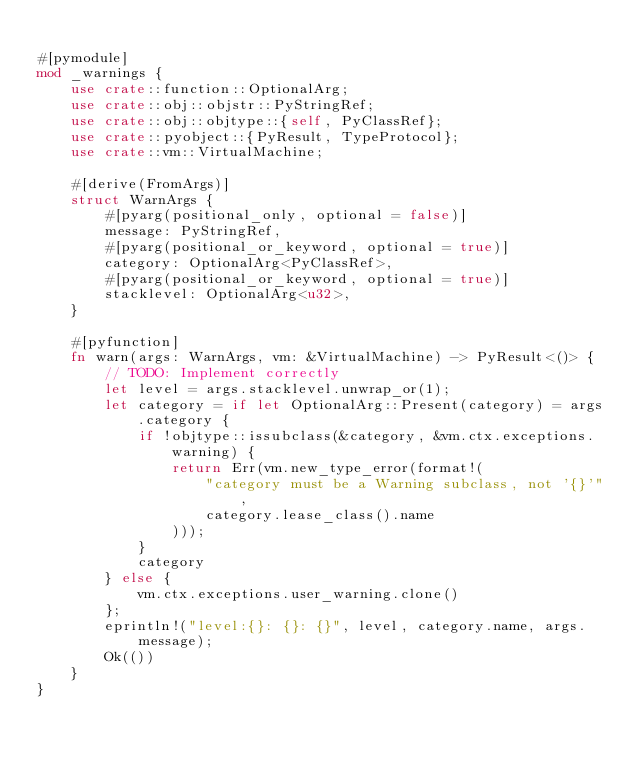<code> <loc_0><loc_0><loc_500><loc_500><_Rust_>
#[pymodule]
mod _warnings {
    use crate::function::OptionalArg;
    use crate::obj::objstr::PyStringRef;
    use crate::obj::objtype::{self, PyClassRef};
    use crate::pyobject::{PyResult, TypeProtocol};
    use crate::vm::VirtualMachine;

    #[derive(FromArgs)]
    struct WarnArgs {
        #[pyarg(positional_only, optional = false)]
        message: PyStringRef,
        #[pyarg(positional_or_keyword, optional = true)]
        category: OptionalArg<PyClassRef>,
        #[pyarg(positional_or_keyword, optional = true)]
        stacklevel: OptionalArg<u32>,
    }

    #[pyfunction]
    fn warn(args: WarnArgs, vm: &VirtualMachine) -> PyResult<()> {
        // TODO: Implement correctly
        let level = args.stacklevel.unwrap_or(1);
        let category = if let OptionalArg::Present(category) = args.category {
            if !objtype::issubclass(&category, &vm.ctx.exceptions.warning) {
                return Err(vm.new_type_error(format!(
                    "category must be a Warning subclass, not '{}'",
                    category.lease_class().name
                )));
            }
            category
        } else {
            vm.ctx.exceptions.user_warning.clone()
        };
        eprintln!("level:{}: {}: {}", level, category.name, args.message);
        Ok(())
    }
}
</code> 